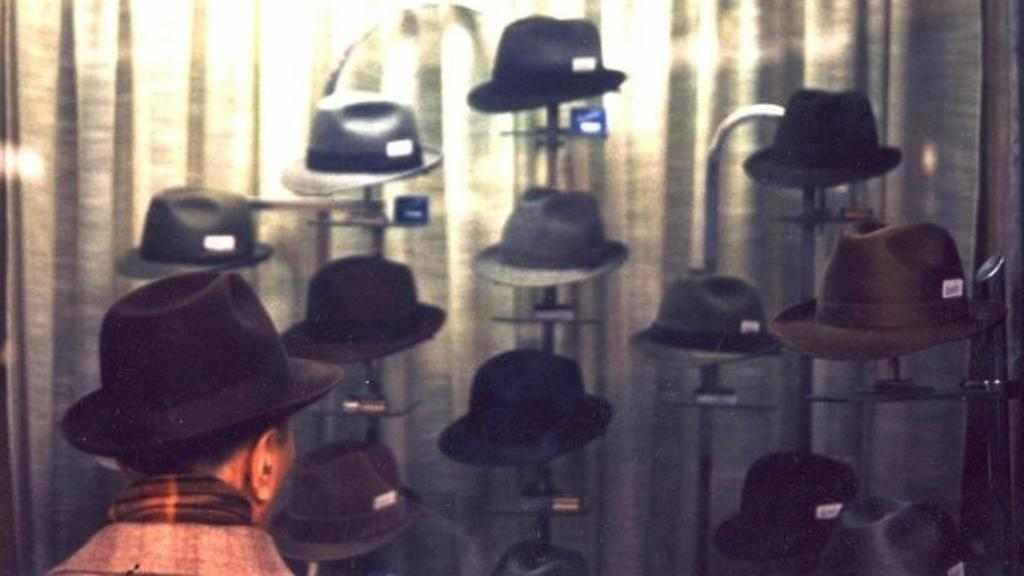Who is present in the image? There is a man in the image. What is the man wearing on his head? The man is wearing a hat. Are there any other hats visible in the image? Yes, there are hats visible in the background of the image. What type of flesh can be seen on the rabbits in the image? There are no rabbits present in the image, so it is not possible to determine what type of flesh might be visible. 